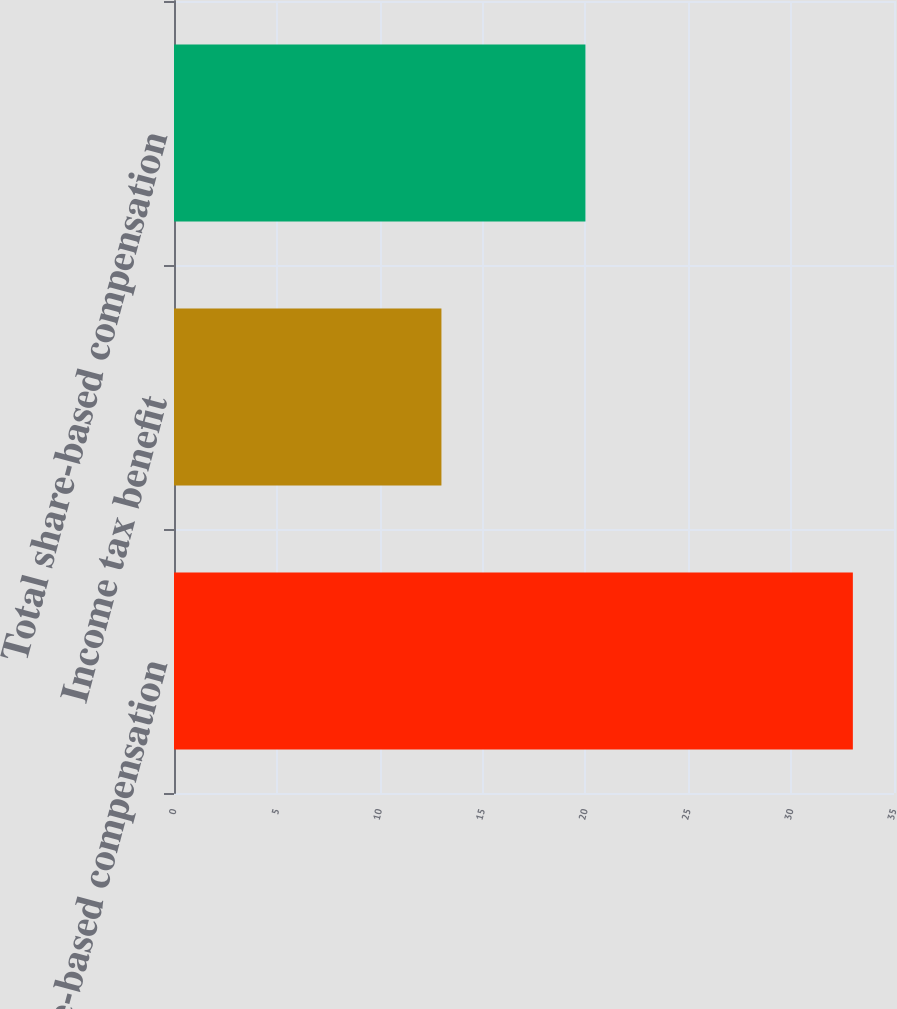<chart> <loc_0><loc_0><loc_500><loc_500><bar_chart><fcel>Share-based compensation<fcel>Income tax benefit<fcel>Total share-based compensation<nl><fcel>33<fcel>13<fcel>20<nl></chart> 